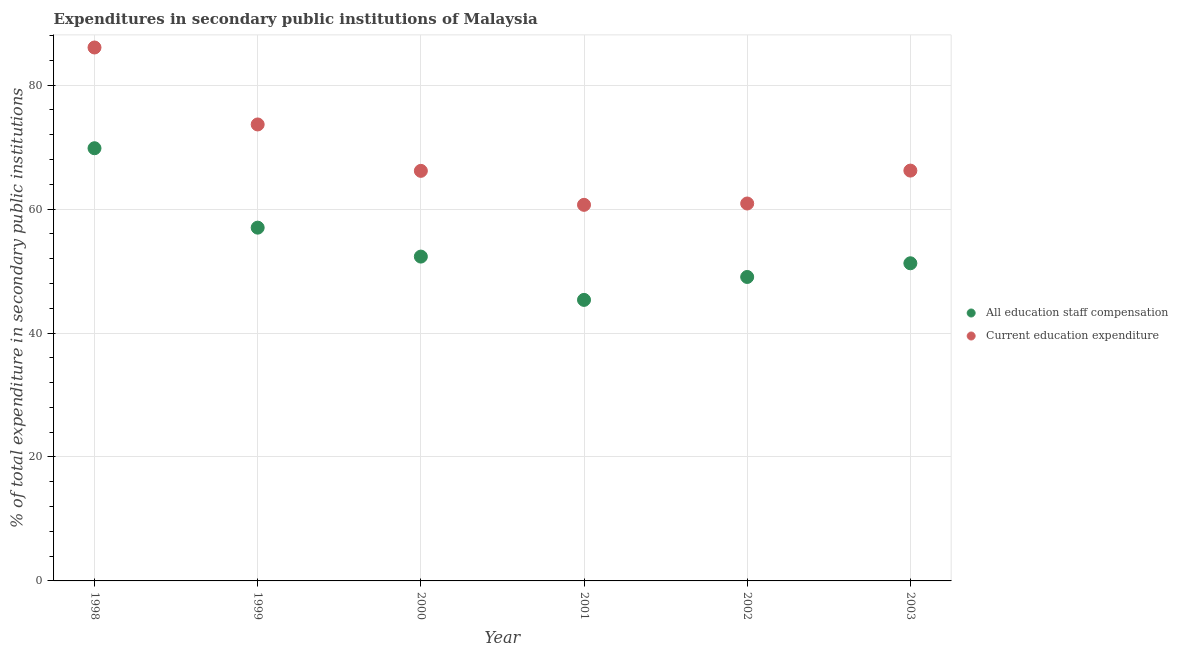What is the expenditure in staff compensation in 2002?
Your response must be concise. 49.05. Across all years, what is the maximum expenditure in staff compensation?
Provide a succinct answer. 69.82. Across all years, what is the minimum expenditure in education?
Your response must be concise. 60.69. In which year was the expenditure in education maximum?
Provide a succinct answer. 1998. In which year was the expenditure in staff compensation minimum?
Your answer should be very brief. 2001. What is the total expenditure in education in the graph?
Your answer should be very brief. 413.72. What is the difference between the expenditure in staff compensation in 2000 and that in 2003?
Provide a succinct answer. 1.08. What is the difference between the expenditure in staff compensation in 2002 and the expenditure in education in 1998?
Provide a short and direct response. -37.03. What is the average expenditure in staff compensation per year?
Provide a succinct answer. 54.14. In the year 2000, what is the difference between the expenditure in education and expenditure in staff compensation?
Offer a terse response. 13.83. What is the ratio of the expenditure in staff compensation in 2001 to that in 2002?
Your answer should be compact. 0.92. Is the expenditure in education in 2002 less than that in 2003?
Offer a terse response. Yes. What is the difference between the highest and the second highest expenditure in staff compensation?
Offer a very short reply. 12.82. What is the difference between the highest and the lowest expenditure in education?
Your answer should be very brief. 25.39. In how many years, is the expenditure in staff compensation greater than the average expenditure in staff compensation taken over all years?
Offer a terse response. 2. Is the sum of the expenditure in staff compensation in 1998 and 2000 greater than the maximum expenditure in education across all years?
Keep it short and to the point. Yes. Does the expenditure in education monotonically increase over the years?
Keep it short and to the point. No. How many years are there in the graph?
Offer a terse response. 6. Are the values on the major ticks of Y-axis written in scientific E-notation?
Keep it short and to the point. No. Does the graph contain any zero values?
Provide a short and direct response. No. Does the graph contain grids?
Make the answer very short. Yes. How many legend labels are there?
Your response must be concise. 2. What is the title of the graph?
Your answer should be compact. Expenditures in secondary public institutions of Malaysia. Does "IMF concessional" appear as one of the legend labels in the graph?
Give a very brief answer. No. What is the label or title of the X-axis?
Make the answer very short. Year. What is the label or title of the Y-axis?
Ensure brevity in your answer.  % of total expenditure in secondary public institutions. What is the % of total expenditure in secondary public institutions of All education staff compensation in 1998?
Make the answer very short. 69.82. What is the % of total expenditure in secondary public institutions of Current education expenditure in 1998?
Ensure brevity in your answer.  86.08. What is the % of total expenditure in secondary public institutions of All education staff compensation in 1999?
Provide a short and direct response. 57.01. What is the % of total expenditure in secondary public institutions in Current education expenditure in 1999?
Ensure brevity in your answer.  73.66. What is the % of total expenditure in secondary public institutions of All education staff compensation in 2000?
Offer a very short reply. 52.34. What is the % of total expenditure in secondary public institutions of Current education expenditure in 2000?
Ensure brevity in your answer.  66.17. What is the % of total expenditure in secondary public institutions in All education staff compensation in 2001?
Ensure brevity in your answer.  45.35. What is the % of total expenditure in secondary public institutions of Current education expenditure in 2001?
Keep it short and to the point. 60.69. What is the % of total expenditure in secondary public institutions of All education staff compensation in 2002?
Provide a succinct answer. 49.05. What is the % of total expenditure in secondary public institutions in Current education expenditure in 2002?
Ensure brevity in your answer.  60.9. What is the % of total expenditure in secondary public institutions in All education staff compensation in 2003?
Your answer should be very brief. 51.26. What is the % of total expenditure in secondary public institutions in Current education expenditure in 2003?
Offer a very short reply. 66.21. Across all years, what is the maximum % of total expenditure in secondary public institutions of All education staff compensation?
Offer a very short reply. 69.82. Across all years, what is the maximum % of total expenditure in secondary public institutions of Current education expenditure?
Provide a succinct answer. 86.08. Across all years, what is the minimum % of total expenditure in secondary public institutions in All education staff compensation?
Your response must be concise. 45.35. Across all years, what is the minimum % of total expenditure in secondary public institutions of Current education expenditure?
Give a very brief answer. 60.69. What is the total % of total expenditure in secondary public institutions in All education staff compensation in the graph?
Make the answer very short. 324.83. What is the total % of total expenditure in secondary public institutions of Current education expenditure in the graph?
Keep it short and to the point. 413.72. What is the difference between the % of total expenditure in secondary public institutions in All education staff compensation in 1998 and that in 1999?
Offer a terse response. 12.82. What is the difference between the % of total expenditure in secondary public institutions of Current education expenditure in 1998 and that in 1999?
Give a very brief answer. 12.42. What is the difference between the % of total expenditure in secondary public institutions in All education staff compensation in 1998 and that in 2000?
Keep it short and to the point. 17.49. What is the difference between the % of total expenditure in secondary public institutions of Current education expenditure in 1998 and that in 2000?
Your response must be concise. 19.91. What is the difference between the % of total expenditure in secondary public institutions in All education staff compensation in 1998 and that in 2001?
Offer a terse response. 24.47. What is the difference between the % of total expenditure in secondary public institutions of Current education expenditure in 1998 and that in 2001?
Your answer should be very brief. 25.39. What is the difference between the % of total expenditure in secondary public institutions in All education staff compensation in 1998 and that in 2002?
Give a very brief answer. 20.77. What is the difference between the % of total expenditure in secondary public institutions in Current education expenditure in 1998 and that in 2002?
Ensure brevity in your answer.  25.17. What is the difference between the % of total expenditure in secondary public institutions in All education staff compensation in 1998 and that in 2003?
Offer a very short reply. 18.56. What is the difference between the % of total expenditure in secondary public institutions in Current education expenditure in 1998 and that in 2003?
Provide a succinct answer. 19.87. What is the difference between the % of total expenditure in secondary public institutions of All education staff compensation in 1999 and that in 2000?
Give a very brief answer. 4.67. What is the difference between the % of total expenditure in secondary public institutions in Current education expenditure in 1999 and that in 2000?
Offer a very short reply. 7.49. What is the difference between the % of total expenditure in secondary public institutions of All education staff compensation in 1999 and that in 2001?
Your response must be concise. 11.66. What is the difference between the % of total expenditure in secondary public institutions of Current education expenditure in 1999 and that in 2001?
Your answer should be very brief. 12.97. What is the difference between the % of total expenditure in secondary public institutions in All education staff compensation in 1999 and that in 2002?
Ensure brevity in your answer.  7.96. What is the difference between the % of total expenditure in secondary public institutions in Current education expenditure in 1999 and that in 2002?
Your answer should be very brief. 12.76. What is the difference between the % of total expenditure in secondary public institutions in All education staff compensation in 1999 and that in 2003?
Provide a succinct answer. 5.75. What is the difference between the % of total expenditure in secondary public institutions of Current education expenditure in 1999 and that in 2003?
Offer a very short reply. 7.45. What is the difference between the % of total expenditure in secondary public institutions of All education staff compensation in 2000 and that in 2001?
Make the answer very short. 6.99. What is the difference between the % of total expenditure in secondary public institutions of Current education expenditure in 2000 and that in 2001?
Provide a succinct answer. 5.48. What is the difference between the % of total expenditure in secondary public institutions in All education staff compensation in 2000 and that in 2002?
Offer a terse response. 3.29. What is the difference between the % of total expenditure in secondary public institutions in Current education expenditure in 2000 and that in 2002?
Your response must be concise. 5.27. What is the difference between the % of total expenditure in secondary public institutions of All education staff compensation in 2000 and that in 2003?
Your response must be concise. 1.08. What is the difference between the % of total expenditure in secondary public institutions of Current education expenditure in 2000 and that in 2003?
Ensure brevity in your answer.  -0.04. What is the difference between the % of total expenditure in secondary public institutions of All education staff compensation in 2001 and that in 2002?
Your answer should be very brief. -3.7. What is the difference between the % of total expenditure in secondary public institutions of Current education expenditure in 2001 and that in 2002?
Your answer should be compact. -0.22. What is the difference between the % of total expenditure in secondary public institutions of All education staff compensation in 2001 and that in 2003?
Your response must be concise. -5.91. What is the difference between the % of total expenditure in secondary public institutions of Current education expenditure in 2001 and that in 2003?
Offer a terse response. -5.52. What is the difference between the % of total expenditure in secondary public institutions in All education staff compensation in 2002 and that in 2003?
Ensure brevity in your answer.  -2.21. What is the difference between the % of total expenditure in secondary public institutions of Current education expenditure in 2002 and that in 2003?
Ensure brevity in your answer.  -5.31. What is the difference between the % of total expenditure in secondary public institutions in All education staff compensation in 1998 and the % of total expenditure in secondary public institutions in Current education expenditure in 1999?
Give a very brief answer. -3.84. What is the difference between the % of total expenditure in secondary public institutions of All education staff compensation in 1998 and the % of total expenditure in secondary public institutions of Current education expenditure in 2000?
Offer a very short reply. 3.65. What is the difference between the % of total expenditure in secondary public institutions of All education staff compensation in 1998 and the % of total expenditure in secondary public institutions of Current education expenditure in 2001?
Provide a succinct answer. 9.13. What is the difference between the % of total expenditure in secondary public institutions of All education staff compensation in 1998 and the % of total expenditure in secondary public institutions of Current education expenditure in 2002?
Your response must be concise. 8.92. What is the difference between the % of total expenditure in secondary public institutions in All education staff compensation in 1998 and the % of total expenditure in secondary public institutions in Current education expenditure in 2003?
Make the answer very short. 3.61. What is the difference between the % of total expenditure in secondary public institutions in All education staff compensation in 1999 and the % of total expenditure in secondary public institutions in Current education expenditure in 2000?
Your answer should be compact. -9.16. What is the difference between the % of total expenditure in secondary public institutions of All education staff compensation in 1999 and the % of total expenditure in secondary public institutions of Current education expenditure in 2001?
Provide a short and direct response. -3.68. What is the difference between the % of total expenditure in secondary public institutions in All education staff compensation in 1999 and the % of total expenditure in secondary public institutions in Current education expenditure in 2002?
Keep it short and to the point. -3.9. What is the difference between the % of total expenditure in secondary public institutions in All education staff compensation in 1999 and the % of total expenditure in secondary public institutions in Current education expenditure in 2003?
Provide a short and direct response. -9.21. What is the difference between the % of total expenditure in secondary public institutions of All education staff compensation in 2000 and the % of total expenditure in secondary public institutions of Current education expenditure in 2001?
Make the answer very short. -8.35. What is the difference between the % of total expenditure in secondary public institutions in All education staff compensation in 2000 and the % of total expenditure in secondary public institutions in Current education expenditure in 2002?
Ensure brevity in your answer.  -8.57. What is the difference between the % of total expenditure in secondary public institutions in All education staff compensation in 2000 and the % of total expenditure in secondary public institutions in Current education expenditure in 2003?
Your answer should be very brief. -13.88. What is the difference between the % of total expenditure in secondary public institutions in All education staff compensation in 2001 and the % of total expenditure in secondary public institutions in Current education expenditure in 2002?
Provide a short and direct response. -15.55. What is the difference between the % of total expenditure in secondary public institutions of All education staff compensation in 2001 and the % of total expenditure in secondary public institutions of Current education expenditure in 2003?
Make the answer very short. -20.86. What is the difference between the % of total expenditure in secondary public institutions in All education staff compensation in 2002 and the % of total expenditure in secondary public institutions in Current education expenditure in 2003?
Make the answer very short. -17.16. What is the average % of total expenditure in secondary public institutions of All education staff compensation per year?
Offer a very short reply. 54.14. What is the average % of total expenditure in secondary public institutions of Current education expenditure per year?
Offer a terse response. 68.95. In the year 1998, what is the difference between the % of total expenditure in secondary public institutions in All education staff compensation and % of total expenditure in secondary public institutions in Current education expenditure?
Give a very brief answer. -16.26. In the year 1999, what is the difference between the % of total expenditure in secondary public institutions in All education staff compensation and % of total expenditure in secondary public institutions in Current education expenditure?
Offer a very short reply. -16.65. In the year 2000, what is the difference between the % of total expenditure in secondary public institutions in All education staff compensation and % of total expenditure in secondary public institutions in Current education expenditure?
Offer a very short reply. -13.83. In the year 2001, what is the difference between the % of total expenditure in secondary public institutions of All education staff compensation and % of total expenditure in secondary public institutions of Current education expenditure?
Make the answer very short. -15.34. In the year 2002, what is the difference between the % of total expenditure in secondary public institutions of All education staff compensation and % of total expenditure in secondary public institutions of Current education expenditure?
Provide a short and direct response. -11.85. In the year 2003, what is the difference between the % of total expenditure in secondary public institutions in All education staff compensation and % of total expenditure in secondary public institutions in Current education expenditure?
Offer a terse response. -14.96. What is the ratio of the % of total expenditure in secondary public institutions of All education staff compensation in 1998 to that in 1999?
Offer a very short reply. 1.22. What is the ratio of the % of total expenditure in secondary public institutions of Current education expenditure in 1998 to that in 1999?
Ensure brevity in your answer.  1.17. What is the ratio of the % of total expenditure in secondary public institutions in All education staff compensation in 1998 to that in 2000?
Your answer should be very brief. 1.33. What is the ratio of the % of total expenditure in secondary public institutions of Current education expenditure in 1998 to that in 2000?
Make the answer very short. 1.3. What is the ratio of the % of total expenditure in secondary public institutions in All education staff compensation in 1998 to that in 2001?
Make the answer very short. 1.54. What is the ratio of the % of total expenditure in secondary public institutions in Current education expenditure in 1998 to that in 2001?
Make the answer very short. 1.42. What is the ratio of the % of total expenditure in secondary public institutions in All education staff compensation in 1998 to that in 2002?
Provide a short and direct response. 1.42. What is the ratio of the % of total expenditure in secondary public institutions in Current education expenditure in 1998 to that in 2002?
Your answer should be very brief. 1.41. What is the ratio of the % of total expenditure in secondary public institutions of All education staff compensation in 1998 to that in 2003?
Your response must be concise. 1.36. What is the ratio of the % of total expenditure in secondary public institutions of All education staff compensation in 1999 to that in 2000?
Give a very brief answer. 1.09. What is the ratio of the % of total expenditure in secondary public institutions of Current education expenditure in 1999 to that in 2000?
Make the answer very short. 1.11. What is the ratio of the % of total expenditure in secondary public institutions of All education staff compensation in 1999 to that in 2001?
Offer a very short reply. 1.26. What is the ratio of the % of total expenditure in secondary public institutions of Current education expenditure in 1999 to that in 2001?
Give a very brief answer. 1.21. What is the ratio of the % of total expenditure in secondary public institutions in All education staff compensation in 1999 to that in 2002?
Provide a short and direct response. 1.16. What is the ratio of the % of total expenditure in secondary public institutions in Current education expenditure in 1999 to that in 2002?
Your answer should be compact. 1.21. What is the ratio of the % of total expenditure in secondary public institutions of All education staff compensation in 1999 to that in 2003?
Provide a short and direct response. 1.11. What is the ratio of the % of total expenditure in secondary public institutions of Current education expenditure in 1999 to that in 2003?
Offer a very short reply. 1.11. What is the ratio of the % of total expenditure in secondary public institutions in All education staff compensation in 2000 to that in 2001?
Offer a terse response. 1.15. What is the ratio of the % of total expenditure in secondary public institutions in Current education expenditure in 2000 to that in 2001?
Give a very brief answer. 1.09. What is the ratio of the % of total expenditure in secondary public institutions in All education staff compensation in 2000 to that in 2002?
Make the answer very short. 1.07. What is the ratio of the % of total expenditure in secondary public institutions of Current education expenditure in 2000 to that in 2002?
Offer a very short reply. 1.09. What is the ratio of the % of total expenditure in secondary public institutions in All education staff compensation in 2000 to that in 2003?
Give a very brief answer. 1.02. What is the ratio of the % of total expenditure in secondary public institutions of Current education expenditure in 2000 to that in 2003?
Your response must be concise. 1. What is the ratio of the % of total expenditure in secondary public institutions in All education staff compensation in 2001 to that in 2002?
Offer a very short reply. 0.92. What is the ratio of the % of total expenditure in secondary public institutions in Current education expenditure in 2001 to that in 2002?
Your answer should be very brief. 1. What is the ratio of the % of total expenditure in secondary public institutions of All education staff compensation in 2001 to that in 2003?
Provide a succinct answer. 0.88. What is the ratio of the % of total expenditure in secondary public institutions in Current education expenditure in 2001 to that in 2003?
Provide a short and direct response. 0.92. What is the ratio of the % of total expenditure in secondary public institutions in All education staff compensation in 2002 to that in 2003?
Make the answer very short. 0.96. What is the ratio of the % of total expenditure in secondary public institutions in Current education expenditure in 2002 to that in 2003?
Your response must be concise. 0.92. What is the difference between the highest and the second highest % of total expenditure in secondary public institutions of All education staff compensation?
Provide a short and direct response. 12.82. What is the difference between the highest and the second highest % of total expenditure in secondary public institutions of Current education expenditure?
Make the answer very short. 12.42. What is the difference between the highest and the lowest % of total expenditure in secondary public institutions in All education staff compensation?
Your response must be concise. 24.47. What is the difference between the highest and the lowest % of total expenditure in secondary public institutions of Current education expenditure?
Offer a terse response. 25.39. 